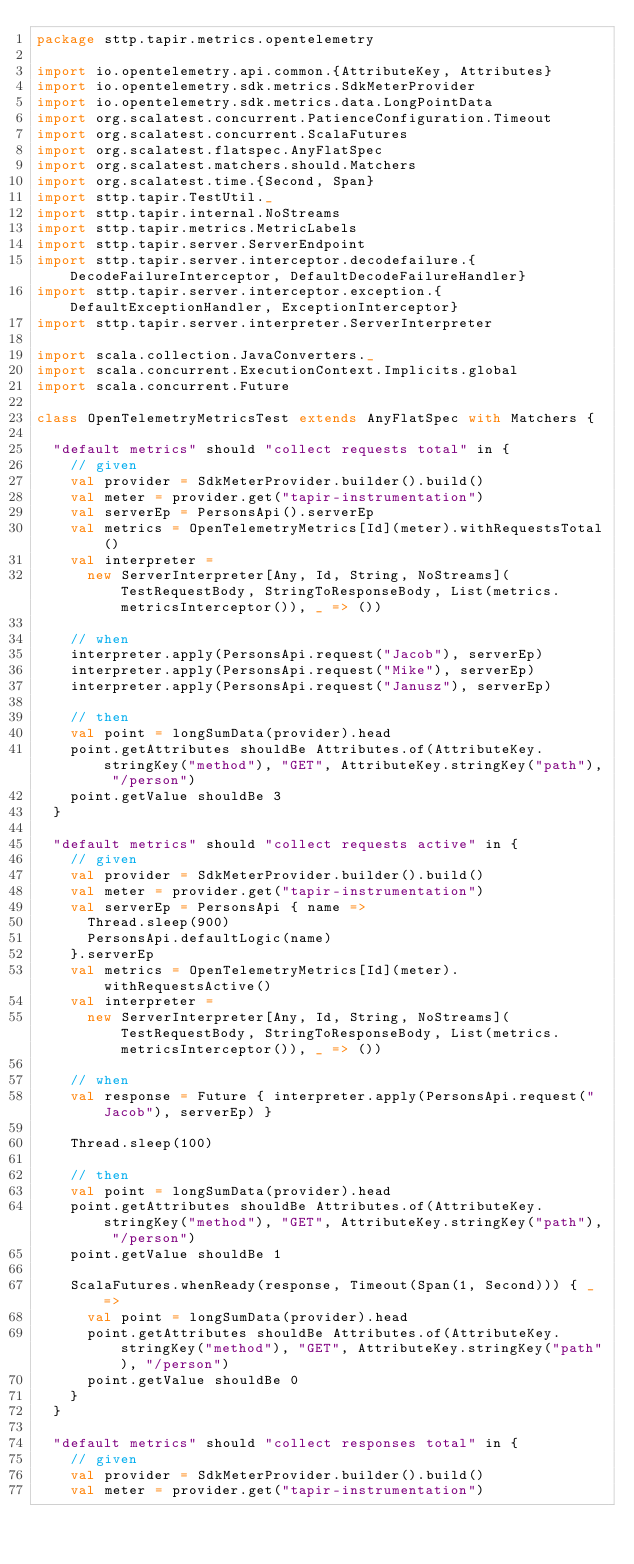Convert code to text. <code><loc_0><loc_0><loc_500><loc_500><_Scala_>package sttp.tapir.metrics.opentelemetry

import io.opentelemetry.api.common.{AttributeKey, Attributes}
import io.opentelemetry.sdk.metrics.SdkMeterProvider
import io.opentelemetry.sdk.metrics.data.LongPointData
import org.scalatest.concurrent.PatienceConfiguration.Timeout
import org.scalatest.concurrent.ScalaFutures
import org.scalatest.flatspec.AnyFlatSpec
import org.scalatest.matchers.should.Matchers
import org.scalatest.time.{Second, Span}
import sttp.tapir.TestUtil._
import sttp.tapir.internal.NoStreams
import sttp.tapir.metrics.MetricLabels
import sttp.tapir.server.ServerEndpoint
import sttp.tapir.server.interceptor.decodefailure.{DecodeFailureInterceptor, DefaultDecodeFailureHandler}
import sttp.tapir.server.interceptor.exception.{DefaultExceptionHandler, ExceptionInterceptor}
import sttp.tapir.server.interpreter.ServerInterpreter

import scala.collection.JavaConverters._
import scala.concurrent.ExecutionContext.Implicits.global
import scala.concurrent.Future

class OpenTelemetryMetricsTest extends AnyFlatSpec with Matchers {

  "default metrics" should "collect requests total" in {
    // given
    val provider = SdkMeterProvider.builder().build()
    val meter = provider.get("tapir-instrumentation")
    val serverEp = PersonsApi().serverEp
    val metrics = OpenTelemetryMetrics[Id](meter).withRequestsTotal()
    val interpreter =
      new ServerInterpreter[Any, Id, String, NoStreams](TestRequestBody, StringToResponseBody, List(metrics.metricsInterceptor()), _ => ())

    // when
    interpreter.apply(PersonsApi.request("Jacob"), serverEp)
    interpreter.apply(PersonsApi.request("Mike"), serverEp)
    interpreter.apply(PersonsApi.request("Janusz"), serverEp)

    // then
    val point = longSumData(provider).head
    point.getAttributes shouldBe Attributes.of(AttributeKey.stringKey("method"), "GET", AttributeKey.stringKey("path"), "/person")
    point.getValue shouldBe 3
  }

  "default metrics" should "collect requests active" in {
    // given
    val provider = SdkMeterProvider.builder().build()
    val meter = provider.get("tapir-instrumentation")
    val serverEp = PersonsApi { name =>
      Thread.sleep(900)
      PersonsApi.defaultLogic(name)
    }.serverEp
    val metrics = OpenTelemetryMetrics[Id](meter).withRequestsActive()
    val interpreter =
      new ServerInterpreter[Any, Id, String, NoStreams](TestRequestBody, StringToResponseBody, List(metrics.metricsInterceptor()), _ => ())

    // when
    val response = Future { interpreter.apply(PersonsApi.request("Jacob"), serverEp) }

    Thread.sleep(100)

    // then
    val point = longSumData(provider).head
    point.getAttributes shouldBe Attributes.of(AttributeKey.stringKey("method"), "GET", AttributeKey.stringKey("path"), "/person")
    point.getValue shouldBe 1

    ScalaFutures.whenReady(response, Timeout(Span(1, Second))) { _ =>
      val point = longSumData(provider).head
      point.getAttributes shouldBe Attributes.of(AttributeKey.stringKey("method"), "GET", AttributeKey.stringKey("path"), "/person")
      point.getValue shouldBe 0
    }
  }

  "default metrics" should "collect responses total" in {
    // given
    val provider = SdkMeterProvider.builder().build()
    val meter = provider.get("tapir-instrumentation")</code> 